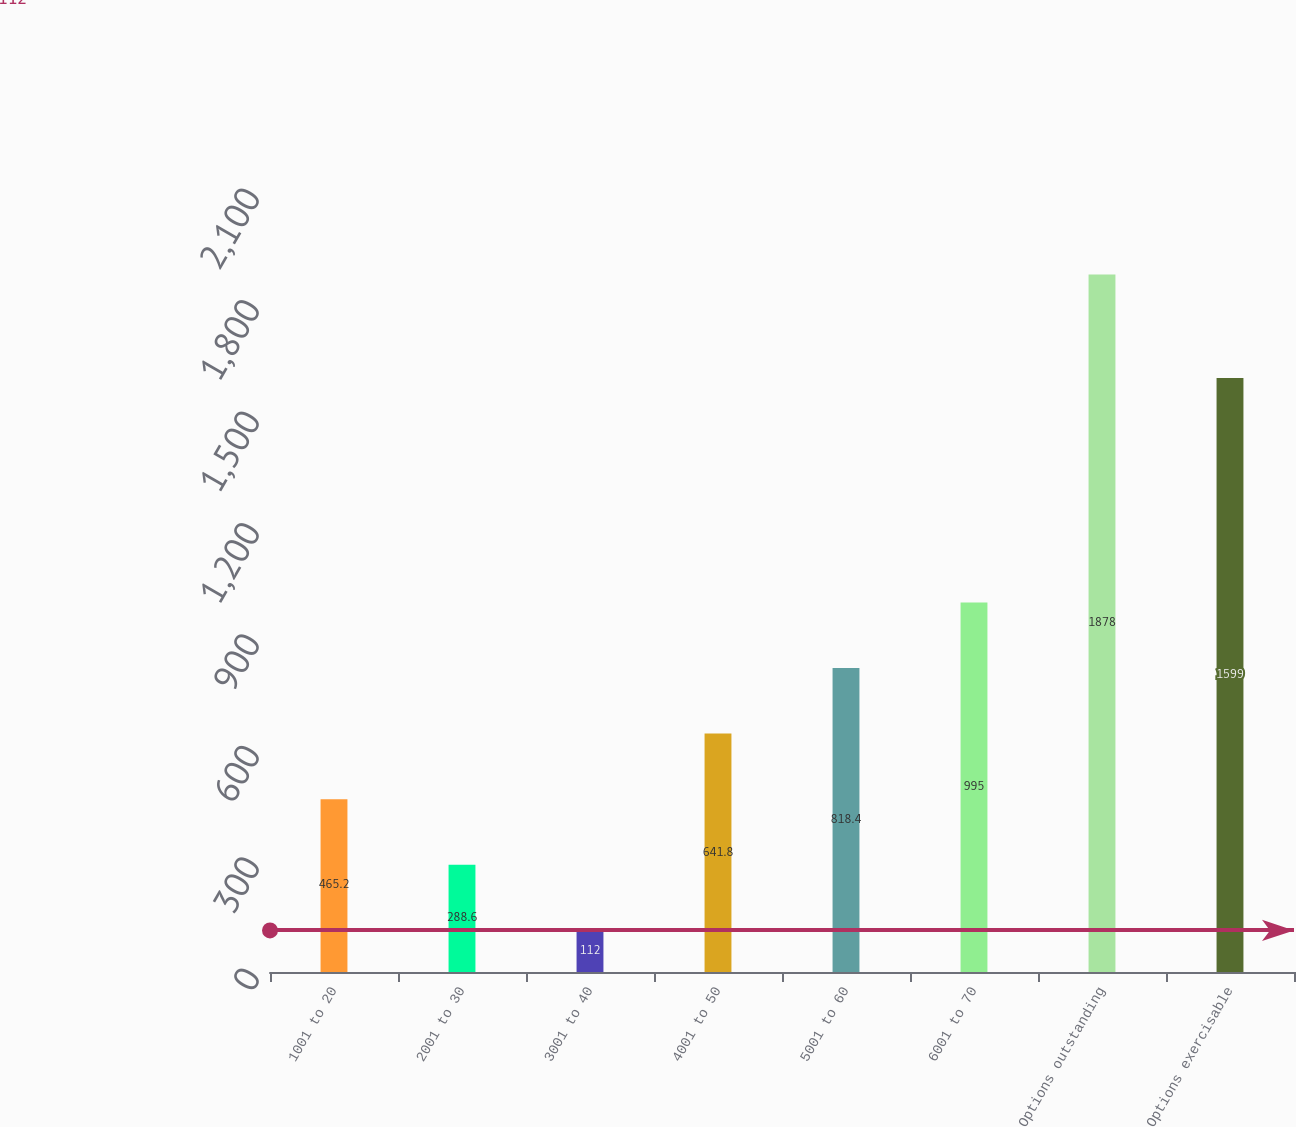Convert chart to OTSL. <chart><loc_0><loc_0><loc_500><loc_500><bar_chart><fcel>1001 to 20<fcel>2001 to 30<fcel>3001 to 40<fcel>4001 to 50<fcel>5001 to 60<fcel>6001 to 70<fcel>Options outstanding<fcel>Options exercisable<nl><fcel>465.2<fcel>288.6<fcel>112<fcel>641.8<fcel>818.4<fcel>995<fcel>1878<fcel>1599<nl></chart> 